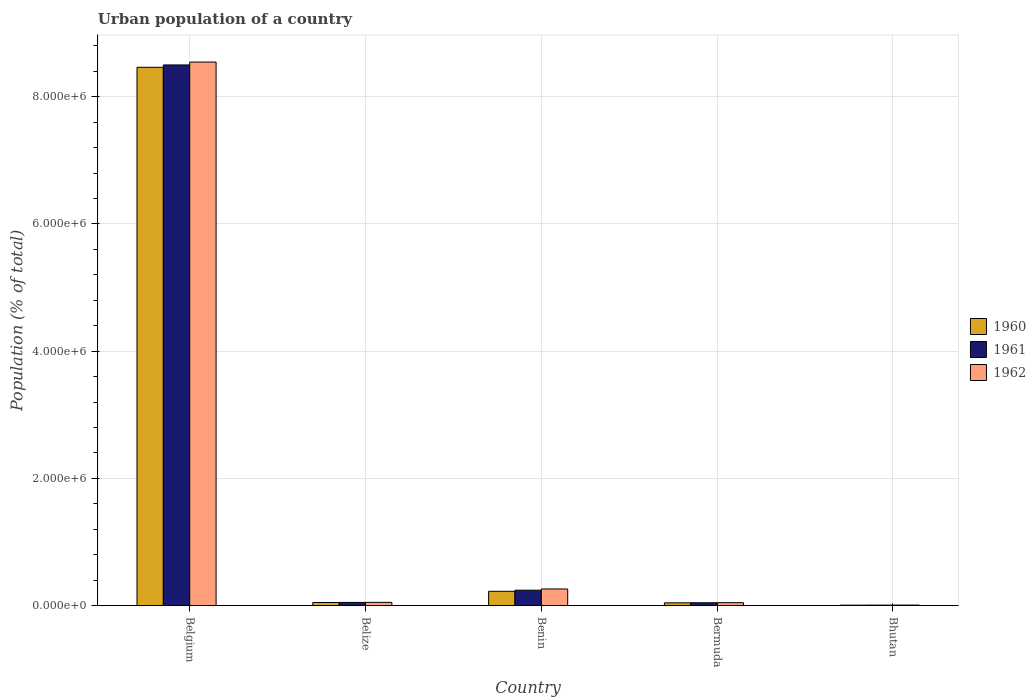How many groups of bars are there?
Offer a terse response. 5. Are the number of bars on each tick of the X-axis equal?
Your response must be concise. Yes. What is the label of the 5th group of bars from the left?
Provide a short and direct response. Bhutan. In how many cases, is the number of bars for a given country not equal to the number of legend labels?
Offer a very short reply. 0. What is the urban population in 1961 in Bhutan?
Your answer should be very brief. 8695. Across all countries, what is the maximum urban population in 1962?
Provide a short and direct response. 8.55e+06. Across all countries, what is the minimum urban population in 1961?
Offer a terse response. 8695. In which country was the urban population in 1961 minimum?
Give a very brief answer. Bhutan. What is the total urban population in 1960 in the graph?
Your answer should be very brief. 8.79e+06. What is the difference between the urban population in 1961 in Benin and that in Bhutan?
Provide a succinct answer. 2.34e+05. What is the difference between the urban population in 1962 in Bermuda and the urban population in 1961 in Belize?
Offer a very short reply. -4273. What is the average urban population in 1961 per country?
Offer a very short reply. 1.77e+06. What is the difference between the urban population of/in 1962 and urban population of/in 1961 in Bhutan?
Your answer should be very brief. 691. In how many countries, is the urban population in 1962 greater than 800000 %?
Ensure brevity in your answer.  1. What is the ratio of the urban population in 1960 in Belize to that in Benin?
Offer a very short reply. 0.22. Is the urban population in 1962 in Bermuda less than that in Bhutan?
Ensure brevity in your answer.  No. What is the difference between the highest and the second highest urban population in 1960?
Your answer should be compact. 8.24e+06. What is the difference between the highest and the lowest urban population in 1960?
Offer a very short reply. 8.46e+06. In how many countries, is the urban population in 1960 greater than the average urban population in 1960 taken over all countries?
Provide a succinct answer. 1. What does the 2nd bar from the left in Belgium represents?
Keep it short and to the point. 1961. What does the 1st bar from the right in Benin represents?
Your answer should be compact. 1962. Is it the case that in every country, the sum of the urban population in 1962 and urban population in 1960 is greater than the urban population in 1961?
Your answer should be very brief. Yes. How many bars are there?
Provide a succinct answer. 15. What is the difference between two consecutive major ticks on the Y-axis?
Provide a short and direct response. 2.00e+06. Are the values on the major ticks of Y-axis written in scientific E-notation?
Give a very brief answer. Yes. Does the graph contain any zero values?
Offer a very short reply. No. Does the graph contain grids?
Provide a short and direct response. Yes. How many legend labels are there?
Your answer should be very brief. 3. What is the title of the graph?
Provide a succinct answer. Urban population of a country. Does "2009" appear as one of the legend labels in the graph?
Ensure brevity in your answer.  No. What is the label or title of the Y-axis?
Your answer should be compact. Population (% of total). What is the Population (% of total) of 1960 in Belgium?
Provide a short and direct response. 8.46e+06. What is the Population (% of total) of 1961 in Belgium?
Provide a short and direct response. 8.50e+06. What is the Population (% of total) of 1962 in Belgium?
Ensure brevity in your answer.  8.55e+06. What is the Population (% of total) of 1960 in Belize?
Provide a short and direct response. 4.97e+04. What is the Population (% of total) in 1961 in Belize?
Your response must be concise. 5.09e+04. What is the Population (% of total) in 1962 in Belize?
Provide a short and direct response. 5.20e+04. What is the Population (% of total) in 1960 in Benin?
Offer a terse response. 2.26e+05. What is the Population (% of total) in 1961 in Benin?
Provide a short and direct response. 2.43e+05. What is the Population (% of total) of 1962 in Benin?
Provide a succinct answer. 2.62e+05. What is the Population (% of total) of 1960 in Bermuda?
Ensure brevity in your answer.  4.44e+04. What is the Population (% of total) of 1961 in Bermuda?
Your response must be concise. 4.55e+04. What is the Population (% of total) in 1962 in Bermuda?
Provide a short and direct response. 4.66e+04. What is the Population (% of total) of 1960 in Bhutan?
Your answer should be very brief. 8059. What is the Population (% of total) in 1961 in Bhutan?
Give a very brief answer. 8695. What is the Population (% of total) in 1962 in Bhutan?
Ensure brevity in your answer.  9386. Across all countries, what is the maximum Population (% of total) in 1960?
Your answer should be compact. 8.46e+06. Across all countries, what is the maximum Population (% of total) in 1961?
Keep it short and to the point. 8.50e+06. Across all countries, what is the maximum Population (% of total) in 1962?
Your response must be concise. 8.55e+06. Across all countries, what is the minimum Population (% of total) in 1960?
Make the answer very short. 8059. Across all countries, what is the minimum Population (% of total) in 1961?
Give a very brief answer. 8695. Across all countries, what is the minimum Population (% of total) of 1962?
Ensure brevity in your answer.  9386. What is the total Population (% of total) in 1960 in the graph?
Offer a terse response. 8.79e+06. What is the total Population (% of total) in 1961 in the graph?
Ensure brevity in your answer.  8.85e+06. What is the total Population (% of total) in 1962 in the graph?
Give a very brief answer. 8.92e+06. What is the difference between the Population (% of total) of 1960 in Belgium and that in Belize?
Your answer should be compact. 8.41e+06. What is the difference between the Population (% of total) of 1961 in Belgium and that in Belize?
Your answer should be very brief. 8.45e+06. What is the difference between the Population (% of total) in 1962 in Belgium and that in Belize?
Make the answer very short. 8.49e+06. What is the difference between the Population (% of total) of 1960 in Belgium and that in Benin?
Give a very brief answer. 8.24e+06. What is the difference between the Population (% of total) in 1961 in Belgium and that in Benin?
Make the answer very short. 8.26e+06. What is the difference between the Population (% of total) in 1962 in Belgium and that in Benin?
Give a very brief answer. 8.28e+06. What is the difference between the Population (% of total) of 1960 in Belgium and that in Bermuda?
Your answer should be very brief. 8.42e+06. What is the difference between the Population (% of total) of 1961 in Belgium and that in Bermuda?
Offer a very short reply. 8.45e+06. What is the difference between the Population (% of total) of 1962 in Belgium and that in Bermuda?
Ensure brevity in your answer.  8.50e+06. What is the difference between the Population (% of total) of 1960 in Belgium and that in Bhutan?
Provide a short and direct response. 8.46e+06. What is the difference between the Population (% of total) of 1961 in Belgium and that in Bhutan?
Your response must be concise. 8.49e+06. What is the difference between the Population (% of total) in 1962 in Belgium and that in Bhutan?
Ensure brevity in your answer.  8.54e+06. What is the difference between the Population (% of total) in 1960 in Belize and that in Benin?
Ensure brevity in your answer.  -1.76e+05. What is the difference between the Population (% of total) of 1961 in Belize and that in Benin?
Provide a short and direct response. -1.92e+05. What is the difference between the Population (% of total) of 1962 in Belize and that in Benin?
Give a very brief answer. -2.10e+05. What is the difference between the Population (% of total) of 1960 in Belize and that in Bermuda?
Provide a short and direct response. 5342. What is the difference between the Population (% of total) of 1961 in Belize and that in Bermuda?
Ensure brevity in your answer.  5373. What is the difference between the Population (% of total) in 1962 in Belize and that in Bermuda?
Give a very brief answer. 5415. What is the difference between the Population (% of total) of 1960 in Belize and that in Bhutan?
Provide a succinct answer. 4.17e+04. What is the difference between the Population (% of total) of 1961 in Belize and that in Bhutan?
Your answer should be very brief. 4.22e+04. What is the difference between the Population (% of total) of 1962 in Belize and that in Bhutan?
Your answer should be compact. 4.26e+04. What is the difference between the Population (% of total) in 1960 in Benin and that in Bermuda?
Provide a short and direct response. 1.81e+05. What is the difference between the Population (% of total) of 1961 in Benin and that in Bermuda?
Your response must be concise. 1.98e+05. What is the difference between the Population (% of total) of 1962 in Benin and that in Bermuda?
Offer a very short reply. 2.15e+05. What is the difference between the Population (% of total) in 1960 in Benin and that in Bhutan?
Provide a succinct answer. 2.17e+05. What is the difference between the Population (% of total) in 1961 in Benin and that in Bhutan?
Offer a terse response. 2.34e+05. What is the difference between the Population (% of total) of 1962 in Benin and that in Bhutan?
Your answer should be compact. 2.53e+05. What is the difference between the Population (% of total) in 1960 in Bermuda and that in Bhutan?
Your answer should be compact. 3.63e+04. What is the difference between the Population (% of total) of 1961 in Bermuda and that in Bhutan?
Your response must be concise. 3.68e+04. What is the difference between the Population (% of total) of 1962 in Bermuda and that in Bhutan?
Your answer should be very brief. 3.72e+04. What is the difference between the Population (% of total) of 1960 in Belgium and the Population (% of total) of 1961 in Belize?
Make the answer very short. 8.41e+06. What is the difference between the Population (% of total) in 1960 in Belgium and the Population (% of total) in 1962 in Belize?
Provide a short and direct response. 8.41e+06. What is the difference between the Population (% of total) in 1961 in Belgium and the Population (% of total) in 1962 in Belize?
Provide a short and direct response. 8.45e+06. What is the difference between the Population (% of total) in 1960 in Belgium and the Population (% of total) in 1961 in Benin?
Your answer should be very brief. 8.22e+06. What is the difference between the Population (% of total) of 1960 in Belgium and the Population (% of total) of 1962 in Benin?
Provide a succinct answer. 8.20e+06. What is the difference between the Population (% of total) of 1961 in Belgium and the Population (% of total) of 1962 in Benin?
Give a very brief answer. 8.24e+06. What is the difference between the Population (% of total) of 1960 in Belgium and the Population (% of total) of 1961 in Bermuda?
Provide a succinct answer. 8.42e+06. What is the difference between the Population (% of total) of 1960 in Belgium and the Population (% of total) of 1962 in Bermuda?
Keep it short and to the point. 8.42e+06. What is the difference between the Population (% of total) of 1961 in Belgium and the Population (% of total) of 1962 in Bermuda?
Provide a succinct answer. 8.45e+06. What is the difference between the Population (% of total) of 1960 in Belgium and the Population (% of total) of 1961 in Bhutan?
Provide a succinct answer. 8.45e+06. What is the difference between the Population (% of total) in 1960 in Belgium and the Population (% of total) in 1962 in Bhutan?
Ensure brevity in your answer.  8.45e+06. What is the difference between the Population (% of total) in 1961 in Belgium and the Population (% of total) in 1962 in Bhutan?
Offer a terse response. 8.49e+06. What is the difference between the Population (% of total) of 1960 in Belize and the Population (% of total) of 1961 in Benin?
Ensure brevity in your answer.  -1.93e+05. What is the difference between the Population (% of total) of 1960 in Belize and the Population (% of total) of 1962 in Benin?
Your answer should be compact. -2.12e+05. What is the difference between the Population (% of total) of 1961 in Belize and the Population (% of total) of 1962 in Benin?
Provide a succinct answer. -2.11e+05. What is the difference between the Population (% of total) of 1960 in Belize and the Population (% of total) of 1961 in Bermuda?
Your response must be concise. 4242. What is the difference between the Population (% of total) of 1960 in Belize and the Population (% of total) of 1962 in Bermuda?
Give a very brief answer. 3142. What is the difference between the Population (% of total) of 1961 in Belize and the Population (% of total) of 1962 in Bermuda?
Your response must be concise. 4273. What is the difference between the Population (% of total) of 1960 in Belize and the Population (% of total) of 1961 in Bhutan?
Your answer should be very brief. 4.10e+04. What is the difference between the Population (% of total) of 1960 in Belize and the Population (% of total) of 1962 in Bhutan?
Offer a terse response. 4.04e+04. What is the difference between the Population (% of total) in 1961 in Belize and the Population (% of total) in 1962 in Bhutan?
Offer a very short reply. 4.15e+04. What is the difference between the Population (% of total) in 1960 in Benin and the Population (% of total) in 1961 in Bermuda?
Give a very brief answer. 1.80e+05. What is the difference between the Population (% of total) in 1960 in Benin and the Population (% of total) in 1962 in Bermuda?
Provide a succinct answer. 1.79e+05. What is the difference between the Population (% of total) of 1961 in Benin and the Population (% of total) of 1962 in Bermuda?
Ensure brevity in your answer.  1.96e+05. What is the difference between the Population (% of total) of 1960 in Benin and the Population (% of total) of 1961 in Bhutan?
Your answer should be very brief. 2.17e+05. What is the difference between the Population (% of total) of 1960 in Benin and the Population (% of total) of 1962 in Bhutan?
Your answer should be very brief. 2.16e+05. What is the difference between the Population (% of total) of 1961 in Benin and the Population (% of total) of 1962 in Bhutan?
Your response must be concise. 2.34e+05. What is the difference between the Population (% of total) in 1960 in Bermuda and the Population (% of total) in 1961 in Bhutan?
Give a very brief answer. 3.57e+04. What is the difference between the Population (% of total) in 1960 in Bermuda and the Population (% of total) in 1962 in Bhutan?
Ensure brevity in your answer.  3.50e+04. What is the difference between the Population (% of total) in 1961 in Bermuda and the Population (% of total) in 1962 in Bhutan?
Ensure brevity in your answer.  3.61e+04. What is the average Population (% of total) in 1960 per country?
Offer a very short reply. 1.76e+06. What is the average Population (% of total) of 1961 per country?
Offer a terse response. 1.77e+06. What is the average Population (% of total) in 1962 per country?
Make the answer very short. 1.78e+06. What is the difference between the Population (% of total) in 1960 and Population (% of total) in 1961 in Belgium?
Your answer should be compact. -3.68e+04. What is the difference between the Population (% of total) in 1960 and Population (% of total) in 1962 in Belgium?
Keep it short and to the point. -8.22e+04. What is the difference between the Population (% of total) of 1961 and Population (% of total) of 1962 in Belgium?
Your answer should be very brief. -4.54e+04. What is the difference between the Population (% of total) in 1960 and Population (% of total) in 1961 in Belize?
Offer a terse response. -1131. What is the difference between the Population (% of total) of 1960 and Population (% of total) of 1962 in Belize?
Provide a succinct answer. -2273. What is the difference between the Population (% of total) in 1961 and Population (% of total) in 1962 in Belize?
Your response must be concise. -1142. What is the difference between the Population (% of total) of 1960 and Population (% of total) of 1961 in Benin?
Keep it short and to the point. -1.75e+04. What is the difference between the Population (% of total) of 1960 and Population (% of total) of 1962 in Benin?
Offer a terse response. -3.66e+04. What is the difference between the Population (% of total) in 1961 and Population (% of total) in 1962 in Benin?
Your answer should be compact. -1.90e+04. What is the difference between the Population (% of total) in 1960 and Population (% of total) in 1961 in Bermuda?
Your answer should be compact. -1100. What is the difference between the Population (% of total) of 1960 and Population (% of total) of 1962 in Bermuda?
Give a very brief answer. -2200. What is the difference between the Population (% of total) in 1961 and Population (% of total) in 1962 in Bermuda?
Provide a succinct answer. -1100. What is the difference between the Population (% of total) of 1960 and Population (% of total) of 1961 in Bhutan?
Your answer should be compact. -636. What is the difference between the Population (% of total) in 1960 and Population (% of total) in 1962 in Bhutan?
Give a very brief answer. -1327. What is the difference between the Population (% of total) of 1961 and Population (% of total) of 1962 in Bhutan?
Keep it short and to the point. -691. What is the ratio of the Population (% of total) in 1960 in Belgium to that in Belize?
Give a very brief answer. 170.14. What is the ratio of the Population (% of total) of 1961 in Belgium to that in Belize?
Make the answer very short. 167.08. What is the ratio of the Population (% of total) in 1962 in Belgium to that in Belize?
Provide a short and direct response. 164.29. What is the ratio of the Population (% of total) in 1960 in Belgium to that in Benin?
Your answer should be very brief. 37.53. What is the ratio of the Population (% of total) of 1961 in Belgium to that in Benin?
Offer a terse response. 34.97. What is the ratio of the Population (% of total) in 1962 in Belgium to that in Benin?
Provide a short and direct response. 32.61. What is the ratio of the Population (% of total) in 1960 in Belgium to that in Bermuda?
Your answer should be compact. 190.62. What is the ratio of the Population (% of total) in 1961 in Belgium to that in Bermuda?
Your answer should be compact. 186.82. What is the ratio of the Population (% of total) in 1962 in Belgium to that in Bermuda?
Your response must be concise. 183.38. What is the ratio of the Population (% of total) in 1960 in Belgium to that in Bhutan?
Offer a terse response. 1050.17. What is the ratio of the Population (% of total) in 1961 in Belgium to that in Bhutan?
Your response must be concise. 977.59. What is the ratio of the Population (% of total) in 1962 in Belgium to that in Bhutan?
Give a very brief answer. 910.46. What is the ratio of the Population (% of total) of 1960 in Belize to that in Benin?
Your answer should be very brief. 0.22. What is the ratio of the Population (% of total) of 1961 in Belize to that in Benin?
Make the answer very short. 0.21. What is the ratio of the Population (% of total) of 1962 in Belize to that in Benin?
Give a very brief answer. 0.2. What is the ratio of the Population (% of total) of 1960 in Belize to that in Bermuda?
Keep it short and to the point. 1.12. What is the ratio of the Population (% of total) in 1961 in Belize to that in Bermuda?
Your answer should be very brief. 1.12. What is the ratio of the Population (% of total) in 1962 in Belize to that in Bermuda?
Keep it short and to the point. 1.12. What is the ratio of the Population (% of total) in 1960 in Belize to that in Bhutan?
Ensure brevity in your answer.  6.17. What is the ratio of the Population (% of total) in 1961 in Belize to that in Bhutan?
Provide a succinct answer. 5.85. What is the ratio of the Population (% of total) of 1962 in Belize to that in Bhutan?
Offer a terse response. 5.54. What is the ratio of the Population (% of total) of 1960 in Benin to that in Bermuda?
Provide a succinct answer. 5.08. What is the ratio of the Population (% of total) in 1961 in Benin to that in Bermuda?
Your response must be concise. 5.34. What is the ratio of the Population (% of total) of 1962 in Benin to that in Bermuda?
Offer a very short reply. 5.62. What is the ratio of the Population (% of total) of 1960 in Benin to that in Bhutan?
Provide a succinct answer. 27.99. What is the ratio of the Population (% of total) of 1961 in Benin to that in Bhutan?
Provide a succinct answer. 27.95. What is the ratio of the Population (% of total) in 1962 in Benin to that in Bhutan?
Your response must be concise. 27.92. What is the ratio of the Population (% of total) of 1960 in Bermuda to that in Bhutan?
Make the answer very short. 5.51. What is the ratio of the Population (% of total) in 1961 in Bermuda to that in Bhutan?
Your answer should be compact. 5.23. What is the ratio of the Population (% of total) in 1962 in Bermuda to that in Bhutan?
Provide a short and direct response. 4.96. What is the difference between the highest and the second highest Population (% of total) of 1960?
Make the answer very short. 8.24e+06. What is the difference between the highest and the second highest Population (% of total) of 1961?
Offer a terse response. 8.26e+06. What is the difference between the highest and the second highest Population (% of total) of 1962?
Provide a succinct answer. 8.28e+06. What is the difference between the highest and the lowest Population (% of total) in 1960?
Your answer should be compact. 8.46e+06. What is the difference between the highest and the lowest Population (% of total) of 1961?
Make the answer very short. 8.49e+06. What is the difference between the highest and the lowest Population (% of total) in 1962?
Ensure brevity in your answer.  8.54e+06. 